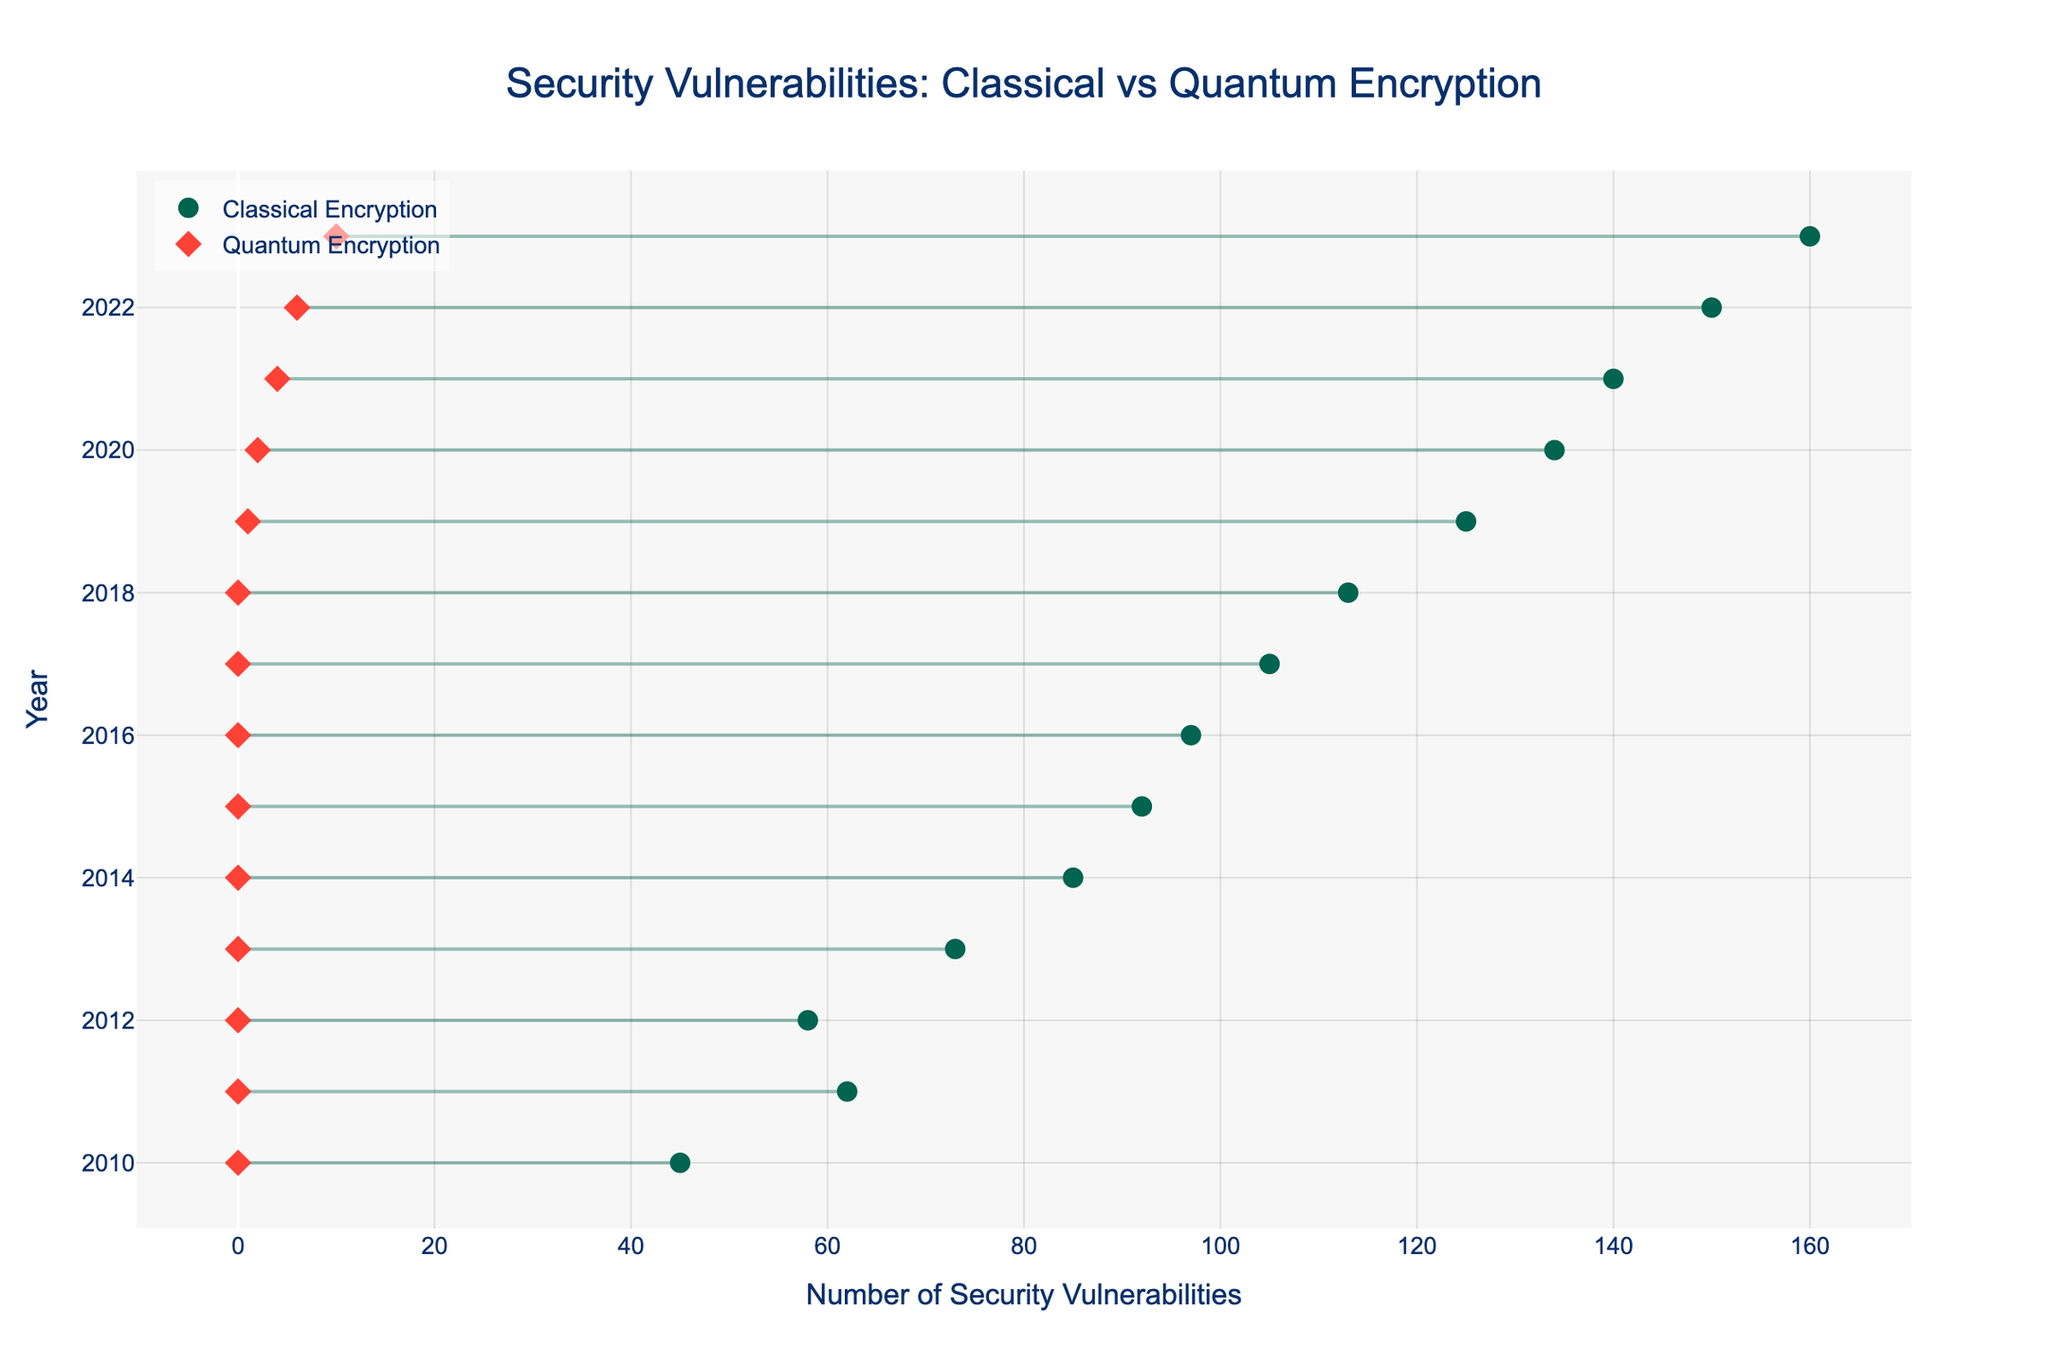what is the title of the plot? The title is usually placed at the top center of the plot. In this case, the title is a descriptive summary of what the plot represents, which can be found at the top of the image.
Answer: Security Vulnerabilities: Classical vs Quantum Encryption which encryption method had the highest number of security vulnerabilities in 2023? Looking at the plot, identify the year 2023 on the y-axis. Follow the line for that year and see which encryption method is linked to the highest point on the x-axis.
Answer: AES-256 how many security vulnerabilities were identified in classical encryption in 2015? Locate the year 2015 on the y-axis, then follow the line for Classical Encryption (usually represented by circles). Read the value on the x-axis.
Answer: 92 what is the difference in the number of security vulnerabilities between classical and quantum encryption methods in 2019? Find the year 2019 on the y-axis. Note the x-axis values for both classical and quantum encryption methods, then subtract the smaller value from the larger one.
Answer: 124 how did the number of security vulnerabilities in quantum encryption change between 2020 and 2023? Identify the x-axis values for quantum encryption for the years 2020 and 2023. Subtract the 2020 value from the 2023 value to determine the change.
Answer: Increased by 8 which year showed the first recorded security vulnerabilities for the quantum proposed method? Look for the first year on the y-axis where the x-axis value is greater than 0 for the quantum encryption method.
Answer: 2019 how does the slope of the line connecting the security vulnerabilities for classical and quantum encryption in 2023 compare to 2010? Examine the lines connecting the points for each year mentioned. Compare the steepness of the line (slope) in 2023 to that in 2010.
Answer: 2023 steeper than 2010 how many encryption methods were used for classical encryption across the entire period? Count the unique encryption method names mentioned for classical encryption in the hover text or data points across the years.
Answer: Two (AES-128 and AES-256) which year had the highest difference in security vulnerabilities between classical and quantum encryption? Identify the year with the largest gap between the classical and quantum encryption points on the y-axis. Compare the x-axis values to find the maximum difference.
Answer: 2023 what trend does the plot show for the security vulnerabilities in classical encryption over time? Observe the points representing classical encryption over the years and describe the general direction or pattern of these points.
Answer: Increasing trend 